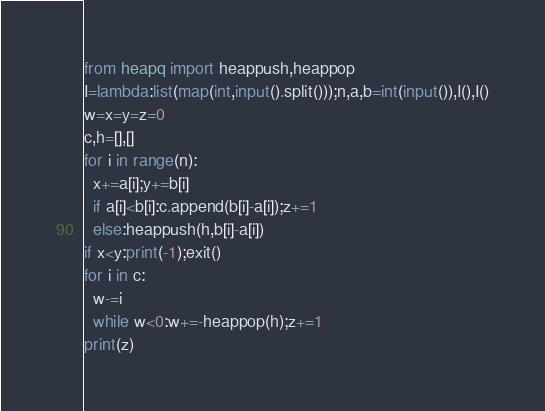<code> <loc_0><loc_0><loc_500><loc_500><_Python_>from heapq import heappush,heappop
I=lambda:list(map(int,input().split()));n,a,b=int(input()),I(),I()
w=x=y=z=0
c,h=[],[]
for i in range(n):
  x+=a[i];y+=b[i]
  if a[i]<b[i]:c.append(b[i]-a[i]);z+=1
  else:heappush(h,b[i]-a[i])
if x<y:print(-1);exit()
for i in c:
  w-=i
  while w<0:w+=-heappop(h);z+=1
print(z)</code> 